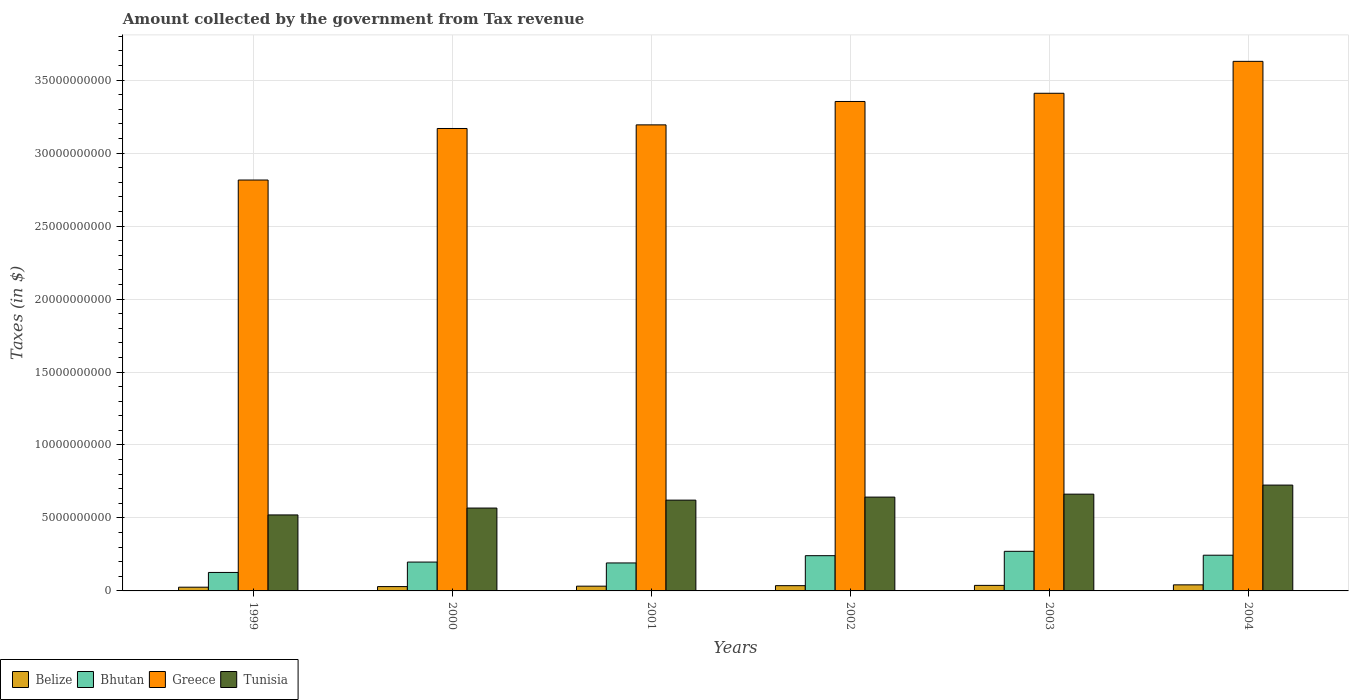How many groups of bars are there?
Keep it short and to the point. 6. Are the number of bars on each tick of the X-axis equal?
Give a very brief answer. Yes. How many bars are there on the 2nd tick from the left?
Make the answer very short. 4. In how many cases, is the number of bars for a given year not equal to the number of legend labels?
Your answer should be compact. 0. What is the amount collected by the government from tax revenue in Belize in 2002?
Your answer should be very brief. 3.60e+08. Across all years, what is the maximum amount collected by the government from tax revenue in Bhutan?
Make the answer very short. 2.71e+09. Across all years, what is the minimum amount collected by the government from tax revenue in Bhutan?
Your answer should be compact. 1.27e+09. In which year was the amount collected by the government from tax revenue in Tunisia maximum?
Provide a short and direct response. 2004. In which year was the amount collected by the government from tax revenue in Tunisia minimum?
Ensure brevity in your answer.  1999. What is the total amount collected by the government from tax revenue in Greece in the graph?
Offer a terse response. 1.96e+11. What is the difference between the amount collected by the government from tax revenue in Greece in 2003 and that in 2004?
Give a very brief answer. -2.19e+09. What is the difference between the amount collected by the government from tax revenue in Belize in 2000 and the amount collected by the government from tax revenue in Bhutan in 2003?
Give a very brief answer. -2.42e+09. What is the average amount collected by the government from tax revenue in Tunisia per year?
Give a very brief answer. 6.24e+09. In the year 2000, what is the difference between the amount collected by the government from tax revenue in Greece and amount collected by the government from tax revenue in Belize?
Give a very brief answer. 3.14e+1. What is the ratio of the amount collected by the government from tax revenue in Tunisia in 1999 to that in 2000?
Offer a terse response. 0.92. What is the difference between the highest and the second highest amount collected by the government from tax revenue in Bhutan?
Provide a short and direct response. 2.67e+08. What is the difference between the highest and the lowest amount collected by the government from tax revenue in Greece?
Make the answer very short. 8.13e+09. What does the 4th bar from the left in 2001 represents?
Your answer should be compact. Tunisia. What does the 3rd bar from the right in 2003 represents?
Your answer should be very brief. Bhutan. Is it the case that in every year, the sum of the amount collected by the government from tax revenue in Bhutan and amount collected by the government from tax revenue in Tunisia is greater than the amount collected by the government from tax revenue in Belize?
Your answer should be compact. Yes. How many years are there in the graph?
Your response must be concise. 6. What is the difference between two consecutive major ticks on the Y-axis?
Ensure brevity in your answer.  5.00e+09. Are the values on the major ticks of Y-axis written in scientific E-notation?
Keep it short and to the point. No. Does the graph contain grids?
Offer a very short reply. Yes. Where does the legend appear in the graph?
Offer a very short reply. Bottom left. How many legend labels are there?
Your answer should be very brief. 4. How are the legend labels stacked?
Ensure brevity in your answer.  Horizontal. What is the title of the graph?
Offer a very short reply. Amount collected by the government from Tax revenue. What is the label or title of the X-axis?
Your response must be concise. Years. What is the label or title of the Y-axis?
Your response must be concise. Taxes (in $). What is the Taxes (in $) of Belize in 1999?
Keep it short and to the point. 2.55e+08. What is the Taxes (in $) in Bhutan in 1999?
Your response must be concise. 1.27e+09. What is the Taxes (in $) in Greece in 1999?
Your response must be concise. 2.82e+1. What is the Taxes (in $) in Tunisia in 1999?
Keep it short and to the point. 5.21e+09. What is the Taxes (in $) of Belize in 2000?
Provide a succinct answer. 2.97e+08. What is the Taxes (in $) in Bhutan in 2000?
Ensure brevity in your answer.  1.98e+09. What is the Taxes (in $) of Greece in 2000?
Your answer should be compact. 3.17e+1. What is the Taxes (in $) in Tunisia in 2000?
Provide a succinct answer. 5.68e+09. What is the Taxes (in $) in Belize in 2001?
Give a very brief answer. 3.26e+08. What is the Taxes (in $) of Bhutan in 2001?
Your response must be concise. 1.92e+09. What is the Taxes (in $) of Greece in 2001?
Offer a very short reply. 3.19e+1. What is the Taxes (in $) of Tunisia in 2001?
Your answer should be compact. 6.22e+09. What is the Taxes (in $) of Belize in 2002?
Provide a short and direct response. 3.60e+08. What is the Taxes (in $) of Bhutan in 2002?
Provide a succinct answer. 2.41e+09. What is the Taxes (in $) in Greece in 2002?
Give a very brief answer. 3.35e+1. What is the Taxes (in $) in Tunisia in 2002?
Keep it short and to the point. 6.43e+09. What is the Taxes (in $) of Belize in 2003?
Make the answer very short. 3.80e+08. What is the Taxes (in $) of Bhutan in 2003?
Make the answer very short. 2.71e+09. What is the Taxes (in $) in Greece in 2003?
Ensure brevity in your answer.  3.41e+1. What is the Taxes (in $) of Tunisia in 2003?
Your answer should be very brief. 6.63e+09. What is the Taxes (in $) in Belize in 2004?
Provide a succinct answer. 4.16e+08. What is the Taxes (in $) of Bhutan in 2004?
Offer a terse response. 2.45e+09. What is the Taxes (in $) in Greece in 2004?
Keep it short and to the point. 3.63e+1. What is the Taxes (in $) in Tunisia in 2004?
Provide a short and direct response. 7.25e+09. Across all years, what is the maximum Taxes (in $) of Belize?
Provide a succinct answer. 4.16e+08. Across all years, what is the maximum Taxes (in $) in Bhutan?
Offer a terse response. 2.71e+09. Across all years, what is the maximum Taxes (in $) in Greece?
Your answer should be compact. 3.63e+1. Across all years, what is the maximum Taxes (in $) of Tunisia?
Give a very brief answer. 7.25e+09. Across all years, what is the minimum Taxes (in $) in Belize?
Keep it short and to the point. 2.55e+08. Across all years, what is the minimum Taxes (in $) of Bhutan?
Provide a succinct answer. 1.27e+09. Across all years, what is the minimum Taxes (in $) in Greece?
Provide a short and direct response. 2.82e+1. Across all years, what is the minimum Taxes (in $) in Tunisia?
Your answer should be compact. 5.21e+09. What is the total Taxes (in $) of Belize in the graph?
Keep it short and to the point. 2.03e+09. What is the total Taxes (in $) of Bhutan in the graph?
Offer a very short reply. 1.27e+1. What is the total Taxes (in $) of Greece in the graph?
Give a very brief answer. 1.96e+11. What is the total Taxes (in $) of Tunisia in the graph?
Provide a short and direct response. 3.74e+1. What is the difference between the Taxes (in $) in Belize in 1999 and that in 2000?
Give a very brief answer. -4.17e+07. What is the difference between the Taxes (in $) in Bhutan in 1999 and that in 2000?
Your answer should be compact. -7.11e+08. What is the difference between the Taxes (in $) in Greece in 1999 and that in 2000?
Keep it short and to the point. -3.53e+09. What is the difference between the Taxes (in $) in Tunisia in 1999 and that in 2000?
Offer a terse response. -4.72e+08. What is the difference between the Taxes (in $) in Belize in 1999 and that in 2001?
Provide a succinct answer. -7.11e+07. What is the difference between the Taxes (in $) of Bhutan in 1999 and that in 2001?
Offer a terse response. -6.51e+08. What is the difference between the Taxes (in $) of Greece in 1999 and that in 2001?
Ensure brevity in your answer.  -3.78e+09. What is the difference between the Taxes (in $) of Tunisia in 1999 and that in 2001?
Give a very brief answer. -1.01e+09. What is the difference between the Taxes (in $) in Belize in 1999 and that in 2002?
Your answer should be compact. -1.05e+08. What is the difference between the Taxes (in $) of Bhutan in 1999 and that in 2002?
Provide a succinct answer. -1.15e+09. What is the difference between the Taxes (in $) in Greece in 1999 and that in 2002?
Provide a short and direct response. -5.38e+09. What is the difference between the Taxes (in $) of Tunisia in 1999 and that in 2002?
Keep it short and to the point. -1.22e+09. What is the difference between the Taxes (in $) in Belize in 1999 and that in 2003?
Give a very brief answer. -1.25e+08. What is the difference between the Taxes (in $) of Bhutan in 1999 and that in 2003?
Your answer should be very brief. -1.45e+09. What is the difference between the Taxes (in $) in Greece in 1999 and that in 2003?
Ensure brevity in your answer.  -5.94e+09. What is the difference between the Taxes (in $) of Tunisia in 1999 and that in 2003?
Ensure brevity in your answer.  -1.42e+09. What is the difference between the Taxes (in $) of Belize in 1999 and that in 2004?
Provide a succinct answer. -1.61e+08. What is the difference between the Taxes (in $) of Bhutan in 1999 and that in 2004?
Provide a succinct answer. -1.18e+09. What is the difference between the Taxes (in $) in Greece in 1999 and that in 2004?
Offer a very short reply. -8.13e+09. What is the difference between the Taxes (in $) in Tunisia in 1999 and that in 2004?
Your answer should be very brief. -2.05e+09. What is the difference between the Taxes (in $) of Belize in 2000 and that in 2001?
Give a very brief answer. -2.94e+07. What is the difference between the Taxes (in $) of Bhutan in 2000 and that in 2001?
Keep it short and to the point. 6.02e+07. What is the difference between the Taxes (in $) in Greece in 2000 and that in 2001?
Your answer should be very brief. -2.48e+08. What is the difference between the Taxes (in $) in Tunisia in 2000 and that in 2001?
Your response must be concise. -5.43e+08. What is the difference between the Taxes (in $) in Belize in 2000 and that in 2002?
Your answer should be very brief. -6.33e+07. What is the difference between the Taxes (in $) of Bhutan in 2000 and that in 2002?
Your response must be concise. -4.37e+08. What is the difference between the Taxes (in $) in Greece in 2000 and that in 2002?
Your answer should be compact. -1.85e+09. What is the difference between the Taxes (in $) in Tunisia in 2000 and that in 2002?
Give a very brief answer. -7.51e+08. What is the difference between the Taxes (in $) in Belize in 2000 and that in 2003?
Your answer should be very brief. -8.31e+07. What is the difference between the Taxes (in $) of Bhutan in 2000 and that in 2003?
Give a very brief answer. -7.36e+08. What is the difference between the Taxes (in $) in Greece in 2000 and that in 2003?
Your response must be concise. -2.41e+09. What is the difference between the Taxes (in $) in Tunisia in 2000 and that in 2003?
Offer a terse response. -9.52e+08. What is the difference between the Taxes (in $) of Belize in 2000 and that in 2004?
Provide a short and direct response. -1.19e+08. What is the difference between the Taxes (in $) in Bhutan in 2000 and that in 2004?
Give a very brief answer. -4.69e+08. What is the difference between the Taxes (in $) in Greece in 2000 and that in 2004?
Your answer should be very brief. -4.60e+09. What is the difference between the Taxes (in $) in Tunisia in 2000 and that in 2004?
Offer a terse response. -1.57e+09. What is the difference between the Taxes (in $) of Belize in 2001 and that in 2002?
Provide a short and direct response. -3.38e+07. What is the difference between the Taxes (in $) in Bhutan in 2001 and that in 2002?
Give a very brief answer. -4.98e+08. What is the difference between the Taxes (in $) in Greece in 2001 and that in 2002?
Provide a short and direct response. -1.60e+09. What is the difference between the Taxes (in $) of Tunisia in 2001 and that in 2002?
Your answer should be compact. -2.08e+08. What is the difference between the Taxes (in $) of Belize in 2001 and that in 2003?
Keep it short and to the point. -5.37e+07. What is the difference between the Taxes (in $) in Bhutan in 2001 and that in 2003?
Keep it short and to the point. -7.97e+08. What is the difference between the Taxes (in $) in Greece in 2001 and that in 2003?
Keep it short and to the point. -2.16e+09. What is the difference between the Taxes (in $) in Tunisia in 2001 and that in 2003?
Give a very brief answer. -4.09e+08. What is the difference between the Taxes (in $) in Belize in 2001 and that in 2004?
Provide a succinct answer. -8.99e+07. What is the difference between the Taxes (in $) in Bhutan in 2001 and that in 2004?
Provide a short and direct response. -5.30e+08. What is the difference between the Taxes (in $) of Greece in 2001 and that in 2004?
Give a very brief answer. -4.35e+09. What is the difference between the Taxes (in $) in Tunisia in 2001 and that in 2004?
Make the answer very short. -1.03e+09. What is the difference between the Taxes (in $) in Belize in 2002 and that in 2003?
Offer a very short reply. -1.98e+07. What is the difference between the Taxes (in $) of Bhutan in 2002 and that in 2003?
Your response must be concise. -2.99e+08. What is the difference between the Taxes (in $) of Greece in 2002 and that in 2003?
Provide a short and direct response. -5.62e+08. What is the difference between the Taxes (in $) in Tunisia in 2002 and that in 2003?
Your answer should be compact. -2.02e+08. What is the difference between the Taxes (in $) in Belize in 2002 and that in 2004?
Make the answer very short. -5.61e+07. What is the difference between the Taxes (in $) in Bhutan in 2002 and that in 2004?
Keep it short and to the point. -3.20e+07. What is the difference between the Taxes (in $) in Greece in 2002 and that in 2004?
Your answer should be very brief. -2.75e+09. What is the difference between the Taxes (in $) of Tunisia in 2002 and that in 2004?
Your answer should be compact. -8.23e+08. What is the difference between the Taxes (in $) in Belize in 2003 and that in 2004?
Ensure brevity in your answer.  -3.62e+07. What is the difference between the Taxes (in $) in Bhutan in 2003 and that in 2004?
Make the answer very short. 2.67e+08. What is the difference between the Taxes (in $) in Greece in 2003 and that in 2004?
Your answer should be compact. -2.19e+09. What is the difference between the Taxes (in $) in Tunisia in 2003 and that in 2004?
Offer a terse response. -6.21e+08. What is the difference between the Taxes (in $) of Belize in 1999 and the Taxes (in $) of Bhutan in 2000?
Offer a terse response. -1.72e+09. What is the difference between the Taxes (in $) in Belize in 1999 and the Taxes (in $) in Greece in 2000?
Your answer should be very brief. -3.14e+1. What is the difference between the Taxes (in $) of Belize in 1999 and the Taxes (in $) of Tunisia in 2000?
Give a very brief answer. -5.42e+09. What is the difference between the Taxes (in $) in Bhutan in 1999 and the Taxes (in $) in Greece in 2000?
Your answer should be compact. -3.04e+1. What is the difference between the Taxes (in $) of Bhutan in 1999 and the Taxes (in $) of Tunisia in 2000?
Your answer should be compact. -4.41e+09. What is the difference between the Taxes (in $) in Greece in 1999 and the Taxes (in $) in Tunisia in 2000?
Offer a terse response. 2.25e+1. What is the difference between the Taxes (in $) in Belize in 1999 and the Taxes (in $) in Bhutan in 2001?
Keep it short and to the point. -1.66e+09. What is the difference between the Taxes (in $) in Belize in 1999 and the Taxes (in $) in Greece in 2001?
Provide a short and direct response. -3.17e+1. What is the difference between the Taxes (in $) in Belize in 1999 and the Taxes (in $) in Tunisia in 2001?
Offer a terse response. -5.97e+09. What is the difference between the Taxes (in $) in Bhutan in 1999 and the Taxes (in $) in Greece in 2001?
Offer a terse response. -3.07e+1. What is the difference between the Taxes (in $) of Bhutan in 1999 and the Taxes (in $) of Tunisia in 2001?
Give a very brief answer. -4.96e+09. What is the difference between the Taxes (in $) of Greece in 1999 and the Taxes (in $) of Tunisia in 2001?
Provide a short and direct response. 2.19e+1. What is the difference between the Taxes (in $) of Belize in 1999 and the Taxes (in $) of Bhutan in 2002?
Your response must be concise. -2.16e+09. What is the difference between the Taxes (in $) in Belize in 1999 and the Taxes (in $) in Greece in 2002?
Provide a succinct answer. -3.33e+1. What is the difference between the Taxes (in $) of Belize in 1999 and the Taxes (in $) of Tunisia in 2002?
Offer a terse response. -6.17e+09. What is the difference between the Taxes (in $) of Bhutan in 1999 and the Taxes (in $) of Greece in 2002?
Provide a succinct answer. -3.23e+1. What is the difference between the Taxes (in $) in Bhutan in 1999 and the Taxes (in $) in Tunisia in 2002?
Ensure brevity in your answer.  -5.16e+09. What is the difference between the Taxes (in $) in Greece in 1999 and the Taxes (in $) in Tunisia in 2002?
Offer a terse response. 2.17e+1. What is the difference between the Taxes (in $) of Belize in 1999 and the Taxes (in $) of Bhutan in 2003?
Offer a very short reply. -2.46e+09. What is the difference between the Taxes (in $) in Belize in 1999 and the Taxes (in $) in Greece in 2003?
Your answer should be compact. -3.38e+1. What is the difference between the Taxes (in $) in Belize in 1999 and the Taxes (in $) in Tunisia in 2003?
Provide a succinct answer. -6.38e+09. What is the difference between the Taxes (in $) of Bhutan in 1999 and the Taxes (in $) of Greece in 2003?
Offer a very short reply. -3.28e+1. What is the difference between the Taxes (in $) in Bhutan in 1999 and the Taxes (in $) in Tunisia in 2003?
Provide a short and direct response. -5.36e+09. What is the difference between the Taxes (in $) of Greece in 1999 and the Taxes (in $) of Tunisia in 2003?
Keep it short and to the point. 2.15e+1. What is the difference between the Taxes (in $) in Belize in 1999 and the Taxes (in $) in Bhutan in 2004?
Provide a short and direct response. -2.19e+09. What is the difference between the Taxes (in $) of Belize in 1999 and the Taxes (in $) of Greece in 2004?
Give a very brief answer. -3.60e+1. What is the difference between the Taxes (in $) of Belize in 1999 and the Taxes (in $) of Tunisia in 2004?
Keep it short and to the point. -7.00e+09. What is the difference between the Taxes (in $) of Bhutan in 1999 and the Taxes (in $) of Greece in 2004?
Your response must be concise. -3.50e+1. What is the difference between the Taxes (in $) in Bhutan in 1999 and the Taxes (in $) in Tunisia in 2004?
Offer a very short reply. -5.99e+09. What is the difference between the Taxes (in $) in Greece in 1999 and the Taxes (in $) in Tunisia in 2004?
Make the answer very short. 2.09e+1. What is the difference between the Taxes (in $) of Belize in 2000 and the Taxes (in $) of Bhutan in 2001?
Your response must be concise. -1.62e+09. What is the difference between the Taxes (in $) in Belize in 2000 and the Taxes (in $) in Greece in 2001?
Offer a very short reply. -3.16e+1. What is the difference between the Taxes (in $) of Belize in 2000 and the Taxes (in $) of Tunisia in 2001?
Provide a short and direct response. -5.92e+09. What is the difference between the Taxes (in $) of Bhutan in 2000 and the Taxes (in $) of Greece in 2001?
Provide a short and direct response. -3.00e+1. What is the difference between the Taxes (in $) of Bhutan in 2000 and the Taxes (in $) of Tunisia in 2001?
Offer a terse response. -4.24e+09. What is the difference between the Taxes (in $) in Greece in 2000 and the Taxes (in $) in Tunisia in 2001?
Your answer should be very brief. 2.55e+1. What is the difference between the Taxes (in $) of Belize in 2000 and the Taxes (in $) of Bhutan in 2002?
Provide a short and direct response. -2.12e+09. What is the difference between the Taxes (in $) of Belize in 2000 and the Taxes (in $) of Greece in 2002?
Offer a terse response. -3.32e+1. What is the difference between the Taxes (in $) in Belize in 2000 and the Taxes (in $) in Tunisia in 2002?
Your response must be concise. -6.13e+09. What is the difference between the Taxes (in $) of Bhutan in 2000 and the Taxes (in $) of Greece in 2002?
Your answer should be compact. -3.16e+1. What is the difference between the Taxes (in $) in Bhutan in 2000 and the Taxes (in $) in Tunisia in 2002?
Your answer should be compact. -4.45e+09. What is the difference between the Taxes (in $) of Greece in 2000 and the Taxes (in $) of Tunisia in 2002?
Make the answer very short. 2.53e+1. What is the difference between the Taxes (in $) of Belize in 2000 and the Taxes (in $) of Bhutan in 2003?
Your answer should be compact. -2.42e+09. What is the difference between the Taxes (in $) of Belize in 2000 and the Taxes (in $) of Greece in 2003?
Provide a short and direct response. -3.38e+1. What is the difference between the Taxes (in $) of Belize in 2000 and the Taxes (in $) of Tunisia in 2003?
Give a very brief answer. -6.33e+09. What is the difference between the Taxes (in $) in Bhutan in 2000 and the Taxes (in $) in Greece in 2003?
Make the answer very short. -3.21e+1. What is the difference between the Taxes (in $) of Bhutan in 2000 and the Taxes (in $) of Tunisia in 2003?
Make the answer very short. -4.65e+09. What is the difference between the Taxes (in $) in Greece in 2000 and the Taxes (in $) in Tunisia in 2003?
Keep it short and to the point. 2.51e+1. What is the difference between the Taxes (in $) in Belize in 2000 and the Taxes (in $) in Bhutan in 2004?
Make the answer very short. -2.15e+09. What is the difference between the Taxes (in $) in Belize in 2000 and the Taxes (in $) in Greece in 2004?
Ensure brevity in your answer.  -3.60e+1. What is the difference between the Taxes (in $) in Belize in 2000 and the Taxes (in $) in Tunisia in 2004?
Offer a terse response. -6.96e+09. What is the difference between the Taxes (in $) in Bhutan in 2000 and the Taxes (in $) in Greece in 2004?
Offer a terse response. -3.43e+1. What is the difference between the Taxes (in $) of Bhutan in 2000 and the Taxes (in $) of Tunisia in 2004?
Give a very brief answer. -5.27e+09. What is the difference between the Taxes (in $) in Greece in 2000 and the Taxes (in $) in Tunisia in 2004?
Provide a short and direct response. 2.44e+1. What is the difference between the Taxes (in $) in Belize in 2001 and the Taxes (in $) in Bhutan in 2002?
Your answer should be compact. -2.09e+09. What is the difference between the Taxes (in $) of Belize in 2001 and the Taxes (in $) of Greece in 2002?
Keep it short and to the point. -3.32e+1. What is the difference between the Taxes (in $) in Belize in 2001 and the Taxes (in $) in Tunisia in 2002?
Offer a terse response. -6.10e+09. What is the difference between the Taxes (in $) in Bhutan in 2001 and the Taxes (in $) in Greece in 2002?
Make the answer very short. -3.16e+1. What is the difference between the Taxes (in $) in Bhutan in 2001 and the Taxes (in $) in Tunisia in 2002?
Your response must be concise. -4.51e+09. What is the difference between the Taxes (in $) of Greece in 2001 and the Taxes (in $) of Tunisia in 2002?
Your answer should be compact. 2.55e+1. What is the difference between the Taxes (in $) of Belize in 2001 and the Taxes (in $) of Bhutan in 2003?
Make the answer very short. -2.39e+09. What is the difference between the Taxes (in $) of Belize in 2001 and the Taxes (in $) of Greece in 2003?
Keep it short and to the point. -3.38e+1. What is the difference between the Taxes (in $) of Belize in 2001 and the Taxes (in $) of Tunisia in 2003?
Provide a succinct answer. -6.30e+09. What is the difference between the Taxes (in $) of Bhutan in 2001 and the Taxes (in $) of Greece in 2003?
Keep it short and to the point. -3.22e+1. What is the difference between the Taxes (in $) of Bhutan in 2001 and the Taxes (in $) of Tunisia in 2003?
Offer a very short reply. -4.71e+09. What is the difference between the Taxes (in $) of Greece in 2001 and the Taxes (in $) of Tunisia in 2003?
Offer a terse response. 2.53e+1. What is the difference between the Taxes (in $) in Belize in 2001 and the Taxes (in $) in Bhutan in 2004?
Your response must be concise. -2.12e+09. What is the difference between the Taxes (in $) of Belize in 2001 and the Taxes (in $) of Greece in 2004?
Make the answer very short. -3.60e+1. What is the difference between the Taxes (in $) in Belize in 2001 and the Taxes (in $) in Tunisia in 2004?
Your answer should be compact. -6.93e+09. What is the difference between the Taxes (in $) in Bhutan in 2001 and the Taxes (in $) in Greece in 2004?
Provide a succinct answer. -3.44e+1. What is the difference between the Taxes (in $) of Bhutan in 2001 and the Taxes (in $) of Tunisia in 2004?
Give a very brief answer. -5.34e+09. What is the difference between the Taxes (in $) in Greece in 2001 and the Taxes (in $) in Tunisia in 2004?
Give a very brief answer. 2.47e+1. What is the difference between the Taxes (in $) of Belize in 2002 and the Taxes (in $) of Bhutan in 2003?
Give a very brief answer. -2.35e+09. What is the difference between the Taxes (in $) in Belize in 2002 and the Taxes (in $) in Greece in 2003?
Offer a very short reply. -3.37e+1. What is the difference between the Taxes (in $) in Belize in 2002 and the Taxes (in $) in Tunisia in 2003?
Give a very brief answer. -6.27e+09. What is the difference between the Taxes (in $) of Bhutan in 2002 and the Taxes (in $) of Greece in 2003?
Give a very brief answer. -3.17e+1. What is the difference between the Taxes (in $) of Bhutan in 2002 and the Taxes (in $) of Tunisia in 2003?
Give a very brief answer. -4.22e+09. What is the difference between the Taxes (in $) of Greece in 2002 and the Taxes (in $) of Tunisia in 2003?
Your answer should be compact. 2.69e+1. What is the difference between the Taxes (in $) in Belize in 2002 and the Taxes (in $) in Bhutan in 2004?
Ensure brevity in your answer.  -2.09e+09. What is the difference between the Taxes (in $) in Belize in 2002 and the Taxes (in $) in Greece in 2004?
Offer a terse response. -3.59e+1. What is the difference between the Taxes (in $) in Belize in 2002 and the Taxes (in $) in Tunisia in 2004?
Provide a short and direct response. -6.89e+09. What is the difference between the Taxes (in $) of Bhutan in 2002 and the Taxes (in $) of Greece in 2004?
Your response must be concise. -3.39e+1. What is the difference between the Taxes (in $) in Bhutan in 2002 and the Taxes (in $) in Tunisia in 2004?
Offer a terse response. -4.84e+09. What is the difference between the Taxes (in $) in Greece in 2002 and the Taxes (in $) in Tunisia in 2004?
Provide a succinct answer. 2.63e+1. What is the difference between the Taxes (in $) in Belize in 2003 and the Taxes (in $) in Bhutan in 2004?
Provide a succinct answer. -2.07e+09. What is the difference between the Taxes (in $) of Belize in 2003 and the Taxes (in $) of Greece in 2004?
Your answer should be compact. -3.59e+1. What is the difference between the Taxes (in $) of Belize in 2003 and the Taxes (in $) of Tunisia in 2004?
Your answer should be compact. -6.87e+09. What is the difference between the Taxes (in $) in Bhutan in 2003 and the Taxes (in $) in Greece in 2004?
Offer a very short reply. -3.36e+1. What is the difference between the Taxes (in $) of Bhutan in 2003 and the Taxes (in $) of Tunisia in 2004?
Give a very brief answer. -4.54e+09. What is the difference between the Taxes (in $) of Greece in 2003 and the Taxes (in $) of Tunisia in 2004?
Make the answer very short. 2.68e+1. What is the average Taxes (in $) in Belize per year?
Make the answer very short. 3.39e+08. What is the average Taxes (in $) in Bhutan per year?
Your answer should be very brief. 2.12e+09. What is the average Taxes (in $) in Greece per year?
Provide a succinct answer. 3.26e+1. What is the average Taxes (in $) in Tunisia per year?
Provide a succinct answer. 6.24e+09. In the year 1999, what is the difference between the Taxes (in $) in Belize and Taxes (in $) in Bhutan?
Keep it short and to the point. -1.01e+09. In the year 1999, what is the difference between the Taxes (in $) in Belize and Taxes (in $) in Greece?
Ensure brevity in your answer.  -2.79e+1. In the year 1999, what is the difference between the Taxes (in $) of Belize and Taxes (in $) of Tunisia?
Offer a terse response. -4.95e+09. In the year 1999, what is the difference between the Taxes (in $) in Bhutan and Taxes (in $) in Greece?
Offer a terse response. -2.69e+1. In the year 1999, what is the difference between the Taxes (in $) in Bhutan and Taxes (in $) in Tunisia?
Give a very brief answer. -3.94e+09. In the year 1999, what is the difference between the Taxes (in $) in Greece and Taxes (in $) in Tunisia?
Your response must be concise. 2.29e+1. In the year 2000, what is the difference between the Taxes (in $) in Belize and Taxes (in $) in Bhutan?
Provide a short and direct response. -1.68e+09. In the year 2000, what is the difference between the Taxes (in $) in Belize and Taxes (in $) in Greece?
Your response must be concise. -3.14e+1. In the year 2000, what is the difference between the Taxes (in $) of Belize and Taxes (in $) of Tunisia?
Offer a terse response. -5.38e+09. In the year 2000, what is the difference between the Taxes (in $) of Bhutan and Taxes (in $) of Greece?
Make the answer very short. -2.97e+1. In the year 2000, what is the difference between the Taxes (in $) in Bhutan and Taxes (in $) in Tunisia?
Offer a very short reply. -3.70e+09. In the year 2000, what is the difference between the Taxes (in $) in Greece and Taxes (in $) in Tunisia?
Your answer should be compact. 2.60e+1. In the year 2001, what is the difference between the Taxes (in $) in Belize and Taxes (in $) in Bhutan?
Make the answer very short. -1.59e+09. In the year 2001, what is the difference between the Taxes (in $) of Belize and Taxes (in $) of Greece?
Provide a short and direct response. -3.16e+1. In the year 2001, what is the difference between the Taxes (in $) in Belize and Taxes (in $) in Tunisia?
Your answer should be compact. -5.90e+09. In the year 2001, what is the difference between the Taxes (in $) in Bhutan and Taxes (in $) in Greece?
Keep it short and to the point. -3.00e+1. In the year 2001, what is the difference between the Taxes (in $) of Bhutan and Taxes (in $) of Tunisia?
Keep it short and to the point. -4.30e+09. In the year 2001, what is the difference between the Taxes (in $) in Greece and Taxes (in $) in Tunisia?
Offer a terse response. 2.57e+1. In the year 2002, what is the difference between the Taxes (in $) of Belize and Taxes (in $) of Bhutan?
Your answer should be compact. -2.05e+09. In the year 2002, what is the difference between the Taxes (in $) in Belize and Taxes (in $) in Greece?
Your answer should be very brief. -3.32e+1. In the year 2002, what is the difference between the Taxes (in $) in Belize and Taxes (in $) in Tunisia?
Provide a short and direct response. -6.07e+09. In the year 2002, what is the difference between the Taxes (in $) of Bhutan and Taxes (in $) of Greece?
Your answer should be very brief. -3.11e+1. In the year 2002, what is the difference between the Taxes (in $) in Bhutan and Taxes (in $) in Tunisia?
Ensure brevity in your answer.  -4.01e+09. In the year 2002, what is the difference between the Taxes (in $) of Greece and Taxes (in $) of Tunisia?
Offer a very short reply. 2.71e+1. In the year 2003, what is the difference between the Taxes (in $) in Belize and Taxes (in $) in Bhutan?
Make the answer very short. -2.33e+09. In the year 2003, what is the difference between the Taxes (in $) in Belize and Taxes (in $) in Greece?
Make the answer very short. -3.37e+1. In the year 2003, what is the difference between the Taxes (in $) of Belize and Taxes (in $) of Tunisia?
Give a very brief answer. -6.25e+09. In the year 2003, what is the difference between the Taxes (in $) in Bhutan and Taxes (in $) in Greece?
Your response must be concise. -3.14e+1. In the year 2003, what is the difference between the Taxes (in $) of Bhutan and Taxes (in $) of Tunisia?
Offer a terse response. -3.92e+09. In the year 2003, what is the difference between the Taxes (in $) in Greece and Taxes (in $) in Tunisia?
Offer a very short reply. 2.75e+1. In the year 2004, what is the difference between the Taxes (in $) in Belize and Taxes (in $) in Bhutan?
Ensure brevity in your answer.  -2.03e+09. In the year 2004, what is the difference between the Taxes (in $) in Belize and Taxes (in $) in Greece?
Your response must be concise. -3.59e+1. In the year 2004, what is the difference between the Taxes (in $) in Belize and Taxes (in $) in Tunisia?
Keep it short and to the point. -6.84e+09. In the year 2004, what is the difference between the Taxes (in $) in Bhutan and Taxes (in $) in Greece?
Ensure brevity in your answer.  -3.38e+1. In the year 2004, what is the difference between the Taxes (in $) in Bhutan and Taxes (in $) in Tunisia?
Your response must be concise. -4.81e+09. In the year 2004, what is the difference between the Taxes (in $) of Greece and Taxes (in $) of Tunisia?
Provide a short and direct response. 2.90e+1. What is the ratio of the Taxes (in $) of Belize in 1999 to that in 2000?
Make the answer very short. 0.86. What is the ratio of the Taxes (in $) in Bhutan in 1999 to that in 2000?
Offer a terse response. 0.64. What is the ratio of the Taxes (in $) of Greece in 1999 to that in 2000?
Your response must be concise. 0.89. What is the ratio of the Taxes (in $) of Tunisia in 1999 to that in 2000?
Ensure brevity in your answer.  0.92. What is the ratio of the Taxes (in $) in Belize in 1999 to that in 2001?
Provide a short and direct response. 0.78. What is the ratio of the Taxes (in $) in Bhutan in 1999 to that in 2001?
Provide a short and direct response. 0.66. What is the ratio of the Taxes (in $) of Greece in 1999 to that in 2001?
Provide a short and direct response. 0.88. What is the ratio of the Taxes (in $) in Tunisia in 1999 to that in 2001?
Your answer should be very brief. 0.84. What is the ratio of the Taxes (in $) of Belize in 1999 to that in 2002?
Ensure brevity in your answer.  0.71. What is the ratio of the Taxes (in $) in Bhutan in 1999 to that in 2002?
Provide a short and direct response. 0.52. What is the ratio of the Taxes (in $) in Greece in 1999 to that in 2002?
Keep it short and to the point. 0.84. What is the ratio of the Taxes (in $) of Tunisia in 1999 to that in 2002?
Offer a very short reply. 0.81. What is the ratio of the Taxes (in $) of Belize in 1999 to that in 2003?
Make the answer very short. 0.67. What is the ratio of the Taxes (in $) of Bhutan in 1999 to that in 2003?
Offer a very short reply. 0.47. What is the ratio of the Taxes (in $) in Greece in 1999 to that in 2003?
Your answer should be compact. 0.83. What is the ratio of the Taxes (in $) in Tunisia in 1999 to that in 2003?
Offer a terse response. 0.79. What is the ratio of the Taxes (in $) in Belize in 1999 to that in 2004?
Make the answer very short. 0.61. What is the ratio of the Taxes (in $) in Bhutan in 1999 to that in 2004?
Provide a succinct answer. 0.52. What is the ratio of the Taxes (in $) of Greece in 1999 to that in 2004?
Make the answer very short. 0.78. What is the ratio of the Taxes (in $) of Tunisia in 1999 to that in 2004?
Give a very brief answer. 0.72. What is the ratio of the Taxes (in $) in Belize in 2000 to that in 2001?
Offer a terse response. 0.91. What is the ratio of the Taxes (in $) in Bhutan in 2000 to that in 2001?
Offer a very short reply. 1.03. What is the ratio of the Taxes (in $) in Tunisia in 2000 to that in 2001?
Your answer should be very brief. 0.91. What is the ratio of the Taxes (in $) of Belize in 2000 to that in 2002?
Your response must be concise. 0.82. What is the ratio of the Taxes (in $) in Bhutan in 2000 to that in 2002?
Offer a very short reply. 0.82. What is the ratio of the Taxes (in $) in Greece in 2000 to that in 2002?
Provide a succinct answer. 0.94. What is the ratio of the Taxes (in $) in Tunisia in 2000 to that in 2002?
Offer a very short reply. 0.88. What is the ratio of the Taxes (in $) in Belize in 2000 to that in 2003?
Make the answer very short. 0.78. What is the ratio of the Taxes (in $) of Bhutan in 2000 to that in 2003?
Your response must be concise. 0.73. What is the ratio of the Taxes (in $) of Greece in 2000 to that in 2003?
Keep it short and to the point. 0.93. What is the ratio of the Taxes (in $) in Tunisia in 2000 to that in 2003?
Keep it short and to the point. 0.86. What is the ratio of the Taxes (in $) in Belize in 2000 to that in 2004?
Your response must be concise. 0.71. What is the ratio of the Taxes (in $) of Bhutan in 2000 to that in 2004?
Make the answer very short. 0.81. What is the ratio of the Taxes (in $) of Greece in 2000 to that in 2004?
Make the answer very short. 0.87. What is the ratio of the Taxes (in $) in Tunisia in 2000 to that in 2004?
Ensure brevity in your answer.  0.78. What is the ratio of the Taxes (in $) of Belize in 2001 to that in 2002?
Keep it short and to the point. 0.91. What is the ratio of the Taxes (in $) in Bhutan in 2001 to that in 2002?
Offer a very short reply. 0.79. What is the ratio of the Taxes (in $) of Greece in 2001 to that in 2002?
Make the answer very short. 0.95. What is the ratio of the Taxes (in $) in Belize in 2001 to that in 2003?
Your answer should be compact. 0.86. What is the ratio of the Taxes (in $) in Bhutan in 2001 to that in 2003?
Ensure brevity in your answer.  0.71. What is the ratio of the Taxes (in $) in Greece in 2001 to that in 2003?
Provide a succinct answer. 0.94. What is the ratio of the Taxes (in $) of Tunisia in 2001 to that in 2003?
Ensure brevity in your answer.  0.94. What is the ratio of the Taxes (in $) of Belize in 2001 to that in 2004?
Keep it short and to the point. 0.78. What is the ratio of the Taxes (in $) of Bhutan in 2001 to that in 2004?
Your answer should be compact. 0.78. What is the ratio of the Taxes (in $) in Greece in 2001 to that in 2004?
Keep it short and to the point. 0.88. What is the ratio of the Taxes (in $) of Tunisia in 2001 to that in 2004?
Provide a succinct answer. 0.86. What is the ratio of the Taxes (in $) in Belize in 2002 to that in 2003?
Give a very brief answer. 0.95. What is the ratio of the Taxes (in $) of Bhutan in 2002 to that in 2003?
Provide a short and direct response. 0.89. What is the ratio of the Taxes (in $) in Greece in 2002 to that in 2003?
Keep it short and to the point. 0.98. What is the ratio of the Taxes (in $) in Tunisia in 2002 to that in 2003?
Make the answer very short. 0.97. What is the ratio of the Taxes (in $) in Belize in 2002 to that in 2004?
Your answer should be compact. 0.87. What is the ratio of the Taxes (in $) in Bhutan in 2002 to that in 2004?
Keep it short and to the point. 0.99. What is the ratio of the Taxes (in $) of Greece in 2002 to that in 2004?
Offer a terse response. 0.92. What is the ratio of the Taxes (in $) of Tunisia in 2002 to that in 2004?
Provide a succinct answer. 0.89. What is the ratio of the Taxes (in $) in Belize in 2003 to that in 2004?
Give a very brief answer. 0.91. What is the ratio of the Taxes (in $) of Bhutan in 2003 to that in 2004?
Offer a terse response. 1.11. What is the ratio of the Taxes (in $) of Greece in 2003 to that in 2004?
Give a very brief answer. 0.94. What is the ratio of the Taxes (in $) in Tunisia in 2003 to that in 2004?
Provide a succinct answer. 0.91. What is the difference between the highest and the second highest Taxes (in $) in Belize?
Make the answer very short. 3.62e+07. What is the difference between the highest and the second highest Taxes (in $) in Bhutan?
Provide a succinct answer. 2.67e+08. What is the difference between the highest and the second highest Taxes (in $) in Greece?
Your answer should be very brief. 2.19e+09. What is the difference between the highest and the second highest Taxes (in $) of Tunisia?
Offer a very short reply. 6.21e+08. What is the difference between the highest and the lowest Taxes (in $) in Belize?
Offer a terse response. 1.61e+08. What is the difference between the highest and the lowest Taxes (in $) of Bhutan?
Provide a short and direct response. 1.45e+09. What is the difference between the highest and the lowest Taxes (in $) of Greece?
Provide a succinct answer. 8.13e+09. What is the difference between the highest and the lowest Taxes (in $) in Tunisia?
Provide a short and direct response. 2.05e+09. 